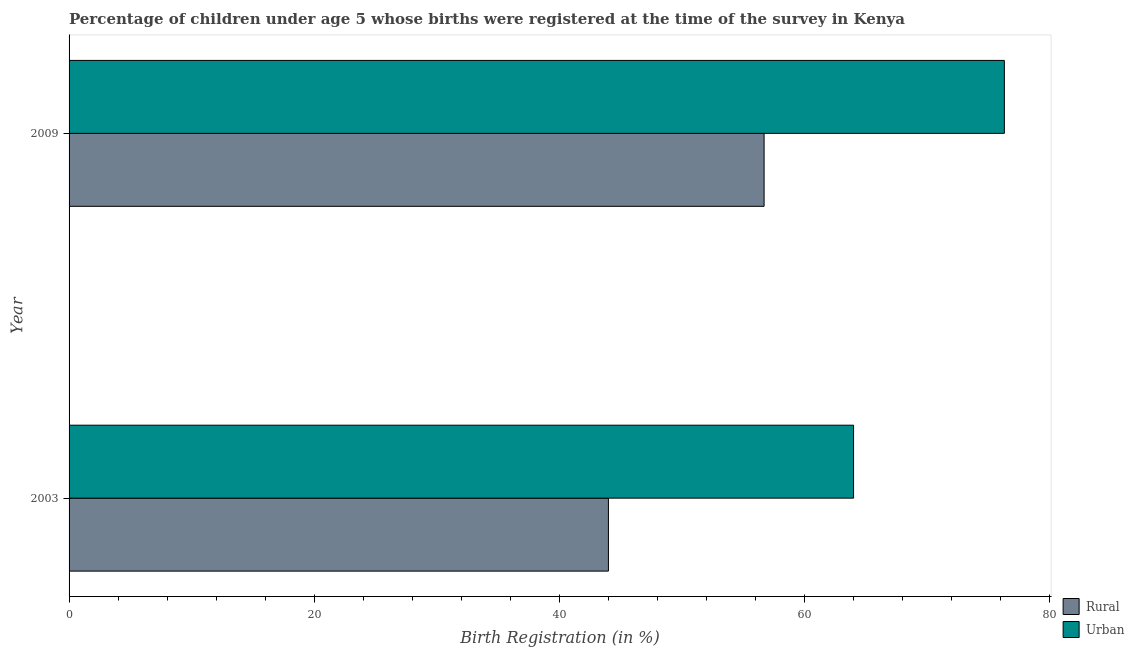How many groups of bars are there?
Your answer should be compact. 2. Are the number of bars per tick equal to the number of legend labels?
Your answer should be compact. Yes. How many bars are there on the 1st tick from the top?
Offer a terse response. 2. How many bars are there on the 2nd tick from the bottom?
Make the answer very short. 2. What is the label of the 1st group of bars from the top?
Your response must be concise. 2009. What is the urban birth registration in 2009?
Keep it short and to the point. 76.3. Across all years, what is the maximum urban birth registration?
Make the answer very short. 76.3. In which year was the urban birth registration maximum?
Provide a short and direct response. 2009. In which year was the urban birth registration minimum?
Your answer should be compact. 2003. What is the total urban birth registration in the graph?
Ensure brevity in your answer.  140.3. What is the difference between the rural birth registration in 2003 and that in 2009?
Your response must be concise. -12.7. What is the difference between the urban birth registration in 2009 and the rural birth registration in 2003?
Offer a very short reply. 32.3. What is the average urban birth registration per year?
Offer a terse response. 70.15. In the year 2009, what is the difference between the urban birth registration and rural birth registration?
Provide a short and direct response. 19.6. In how many years, is the rural birth registration greater than 28 %?
Keep it short and to the point. 2. What is the ratio of the rural birth registration in 2003 to that in 2009?
Your answer should be very brief. 0.78. Is the rural birth registration in 2003 less than that in 2009?
Ensure brevity in your answer.  Yes. Is the difference between the urban birth registration in 2003 and 2009 greater than the difference between the rural birth registration in 2003 and 2009?
Ensure brevity in your answer.  Yes. In how many years, is the urban birth registration greater than the average urban birth registration taken over all years?
Give a very brief answer. 1. What does the 2nd bar from the top in 2003 represents?
Provide a short and direct response. Rural. What does the 2nd bar from the bottom in 2003 represents?
Make the answer very short. Urban. How many bars are there?
Provide a short and direct response. 4. Are all the bars in the graph horizontal?
Provide a succinct answer. Yes. What is the difference between two consecutive major ticks on the X-axis?
Your response must be concise. 20. Are the values on the major ticks of X-axis written in scientific E-notation?
Offer a terse response. No. Does the graph contain grids?
Make the answer very short. No. Where does the legend appear in the graph?
Give a very brief answer. Bottom right. What is the title of the graph?
Your answer should be compact. Percentage of children under age 5 whose births were registered at the time of the survey in Kenya. Does "Private consumption" appear as one of the legend labels in the graph?
Ensure brevity in your answer.  No. What is the label or title of the X-axis?
Offer a very short reply. Birth Registration (in %). What is the Birth Registration (in %) in Rural in 2003?
Your answer should be compact. 44. What is the Birth Registration (in %) in Rural in 2009?
Ensure brevity in your answer.  56.7. What is the Birth Registration (in %) of Urban in 2009?
Ensure brevity in your answer.  76.3. Across all years, what is the maximum Birth Registration (in %) in Rural?
Provide a succinct answer. 56.7. Across all years, what is the maximum Birth Registration (in %) of Urban?
Provide a succinct answer. 76.3. Across all years, what is the minimum Birth Registration (in %) in Rural?
Your answer should be very brief. 44. What is the total Birth Registration (in %) of Rural in the graph?
Give a very brief answer. 100.7. What is the total Birth Registration (in %) in Urban in the graph?
Your response must be concise. 140.3. What is the difference between the Birth Registration (in %) of Rural in 2003 and the Birth Registration (in %) of Urban in 2009?
Your answer should be compact. -32.3. What is the average Birth Registration (in %) of Rural per year?
Provide a short and direct response. 50.35. What is the average Birth Registration (in %) of Urban per year?
Your answer should be very brief. 70.15. In the year 2003, what is the difference between the Birth Registration (in %) of Rural and Birth Registration (in %) of Urban?
Provide a succinct answer. -20. In the year 2009, what is the difference between the Birth Registration (in %) of Rural and Birth Registration (in %) of Urban?
Give a very brief answer. -19.6. What is the ratio of the Birth Registration (in %) of Rural in 2003 to that in 2009?
Ensure brevity in your answer.  0.78. What is the ratio of the Birth Registration (in %) of Urban in 2003 to that in 2009?
Make the answer very short. 0.84. What is the difference between the highest and the lowest Birth Registration (in %) of Rural?
Provide a short and direct response. 12.7. What is the difference between the highest and the lowest Birth Registration (in %) of Urban?
Your answer should be very brief. 12.3. 